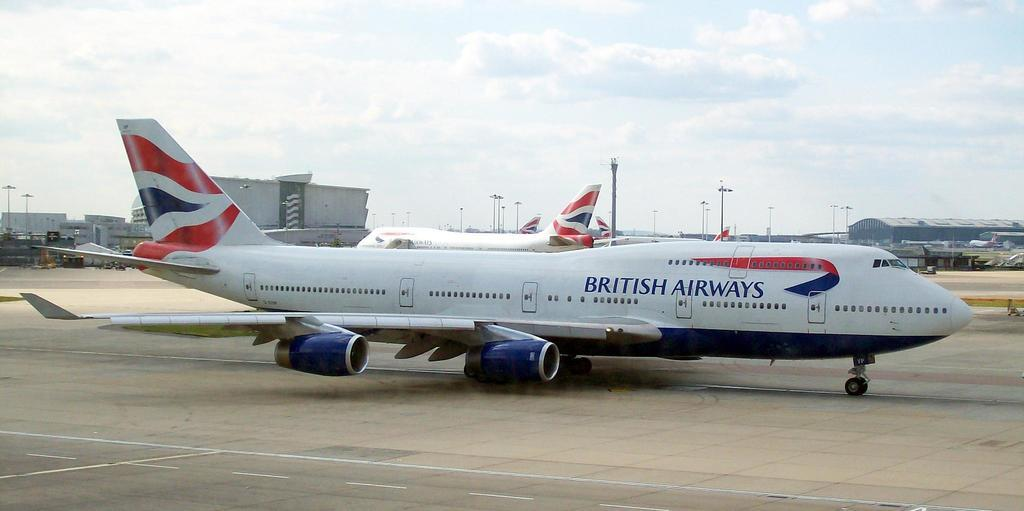<image>
Give a short and clear explanation of the subsequent image. A large British Airways jet is on the ground at an airport. 